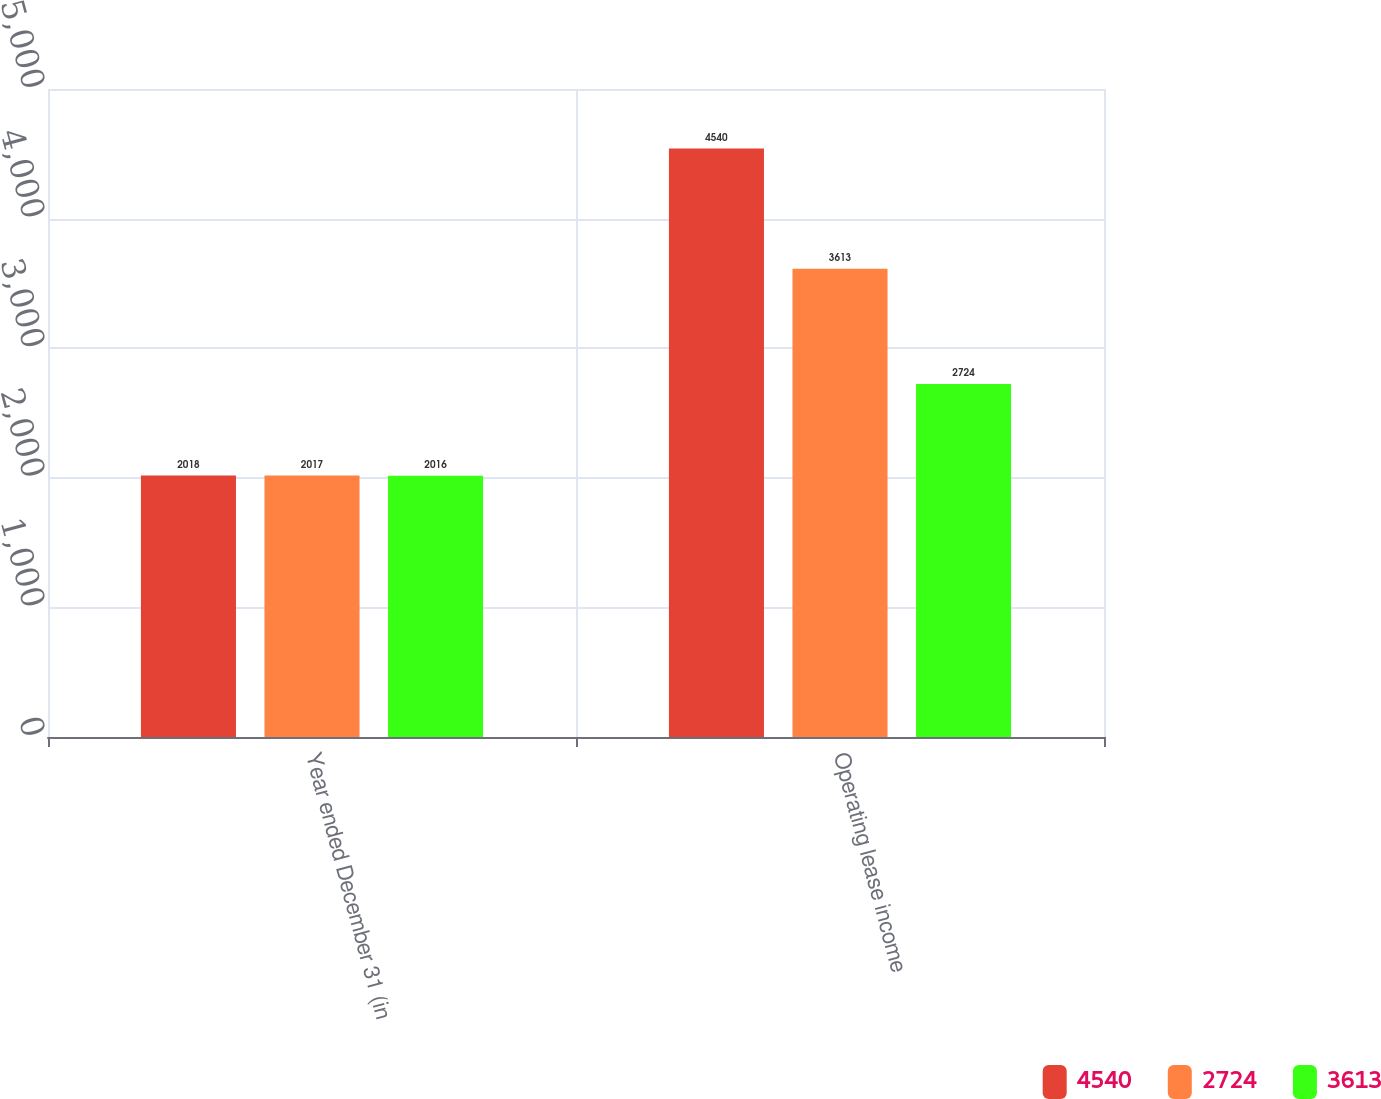Convert chart to OTSL. <chart><loc_0><loc_0><loc_500><loc_500><stacked_bar_chart><ecel><fcel>Year ended December 31 (in<fcel>Operating lease income<nl><fcel>4540<fcel>2018<fcel>4540<nl><fcel>2724<fcel>2017<fcel>3613<nl><fcel>3613<fcel>2016<fcel>2724<nl></chart> 